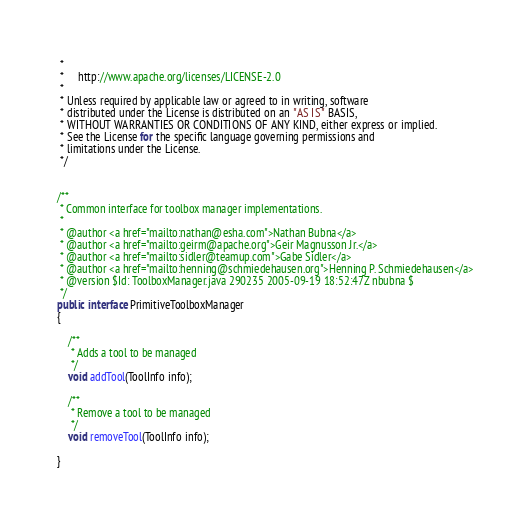<code> <loc_0><loc_0><loc_500><loc_500><_Java_> *
 *     http://www.apache.org/licenses/LICENSE-2.0
 *
 * Unless required by applicable law or agreed to in writing, software
 * distributed under the License is distributed on an "AS IS" BASIS,
 * WITHOUT WARRANTIES OR CONDITIONS OF ANY KIND, either express or implied.
 * See the License for the specific language governing permissions and
 * limitations under the License.
 */


/**
 * Common interface for toolbox manager implementations.
 *
 * @author <a href="mailto:nathan@esha.com">Nathan Bubna</a>
 * @author <a href="mailto:geirm@apache.org">Geir Magnusson Jr.</a>
 * @author <a href="mailto:sidler@teamup.com">Gabe Sidler</a>
 * @author <a href="mailto:henning@schmiedehausen.org">Henning P. Schmiedehausen</a>
 * @version $Id: ToolboxManager.java 290235 2005-09-19 18:52:47Z nbubna $
 */
public interface PrimitiveToolboxManager
{

    /**
     * Adds a tool to be managed
     */
    void addTool(ToolInfo info);
    
    /**
     * Remove a tool to be managed
     */
    void removeTool(ToolInfo info);

}
</code> 